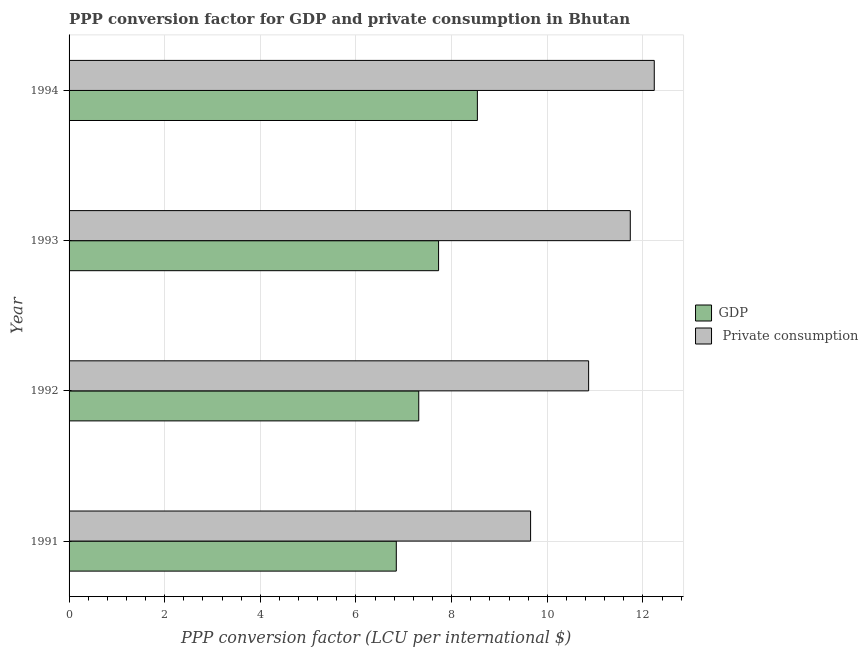How many different coloured bars are there?
Offer a very short reply. 2. How many groups of bars are there?
Your answer should be compact. 4. Are the number of bars per tick equal to the number of legend labels?
Offer a terse response. Yes. Are the number of bars on each tick of the Y-axis equal?
Your answer should be very brief. Yes. What is the label of the 2nd group of bars from the top?
Provide a succinct answer. 1993. What is the ppp conversion factor for private consumption in 1991?
Provide a succinct answer. 9.65. Across all years, what is the maximum ppp conversion factor for private consumption?
Provide a succinct answer. 12.24. Across all years, what is the minimum ppp conversion factor for gdp?
Your answer should be compact. 6.84. In which year was the ppp conversion factor for gdp minimum?
Keep it short and to the point. 1991. What is the total ppp conversion factor for private consumption in the graph?
Give a very brief answer. 44.49. What is the difference between the ppp conversion factor for private consumption in 1991 and that in 1993?
Your response must be concise. -2.08. What is the difference between the ppp conversion factor for gdp in 1994 and the ppp conversion factor for private consumption in 1993?
Offer a very short reply. -3.2. What is the average ppp conversion factor for gdp per year?
Give a very brief answer. 7.61. In the year 1994, what is the difference between the ppp conversion factor for private consumption and ppp conversion factor for gdp?
Ensure brevity in your answer.  3.7. What is the ratio of the ppp conversion factor for gdp in 1991 to that in 1992?
Your answer should be very brief. 0.94. Is the difference between the ppp conversion factor for private consumption in 1991 and 1992 greater than the difference between the ppp conversion factor for gdp in 1991 and 1992?
Ensure brevity in your answer.  No. What is the difference between the highest and the second highest ppp conversion factor for private consumption?
Your answer should be very brief. 0.5. What is the difference between the highest and the lowest ppp conversion factor for private consumption?
Give a very brief answer. 2.59. In how many years, is the ppp conversion factor for gdp greater than the average ppp conversion factor for gdp taken over all years?
Offer a terse response. 2. What does the 2nd bar from the top in 1992 represents?
Offer a very short reply. GDP. What does the 1st bar from the bottom in 1994 represents?
Make the answer very short. GDP. How many bars are there?
Your response must be concise. 8. Are all the bars in the graph horizontal?
Your response must be concise. Yes. How many years are there in the graph?
Your answer should be compact. 4. Does the graph contain any zero values?
Make the answer very short. No. Does the graph contain grids?
Provide a short and direct response. Yes. How many legend labels are there?
Your answer should be very brief. 2. What is the title of the graph?
Provide a succinct answer. PPP conversion factor for GDP and private consumption in Bhutan. What is the label or title of the X-axis?
Offer a terse response. PPP conversion factor (LCU per international $). What is the PPP conversion factor (LCU per international $) of GDP in 1991?
Give a very brief answer. 6.84. What is the PPP conversion factor (LCU per international $) of  Private consumption in 1991?
Your response must be concise. 9.65. What is the PPP conversion factor (LCU per international $) in GDP in 1992?
Offer a very short reply. 7.31. What is the PPP conversion factor (LCU per international $) in  Private consumption in 1992?
Provide a short and direct response. 10.86. What is the PPP conversion factor (LCU per international $) of GDP in 1993?
Your answer should be very brief. 7.73. What is the PPP conversion factor (LCU per international $) of  Private consumption in 1993?
Provide a short and direct response. 11.74. What is the PPP conversion factor (LCU per international $) of GDP in 1994?
Offer a terse response. 8.54. What is the PPP conversion factor (LCU per international $) of  Private consumption in 1994?
Offer a very short reply. 12.24. Across all years, what is the maximum PPP conversion factor (LCU per international $) in GDP?
Provide a short and direct response. 8.54. Across all years, what is the maximum PPP conversion factor (LCU per international $) of  Private consumption?
Make the answer very short. 12.24. Across all years, what is the minimum PPP conversion factor (LCU per international $) of GDP?
Your answer should be compact. 6.84. Across all years, what is the minimum PPP conversion factor (LCU per international $) in  Private consumption?
Offer a terse response. 9.65. What is the total PPP conversion factor (LCU per international $) of GDP in the graph?
Keep it short and to the point. 30.42. What is the total PPP conversion factor (LCU per international $) in  Private consumption in the graph?
Your response must be concise. 44.49. What is the difference between the PPP conversion factor (LCU per international $) of GDP in 1991 and that in 1992?
Provide a succinct answer. -0.47. What is the difference between the PPP conversion factor (LCU per international $) of  Private consumption in 1991 and that in 1992?
Your response must be concise. -1.21. What is the difference between the PPP conversion factor (LCU per international $) of GDP in 1991 and that in 1993?
Give a very brief answer. -0.88. What is the difference between the PPP conversion factor (LCU per international $) in  Private consumption in 1991 and that in 1993?
Offer a terse response. -2.08. What is the difference between the PPP conversion factor (LCU per international $) of GDP in 1991 and that in 1994?
Your answer should be compact. -1.7. What is the difference between the PPP conversion factor (LCU per international $) in  Private consumption in 1991 and that in 1994?
Offer a terse response. -2.59. What is the difference between the PPP conversion factor (LCU per international $) of GDP in 1992 and that in 1993?
Offer a very short reply. -0.41. What is the difference between the PPP conversion factor (LCU per international $) in  Private consumption in 1992 and that in 1993?
Your answer should be very brief. -0.87. What is the difference between the PPP conversion factor (LCU per international $) in GDP in 1992 and that in 1994?
Your answer should be compact. -1.23. What is the difference between the PPP conversion factor (LCU per international $) of  Private consumption in 1992 and that in 1994?
Your response must be concise. -1.37. What is the difference between the PPP conversion factor (LCU per international $) of GDP in 1993 and that in 1994?
Offer a terse response. -0.81. What is the difference between the PPP conversion factor (LCU per international $) in  Private consumption in 1993 and that in 1994?
Provide a succinct answer. -0.5. What is the difference between the PPP conversion factor (LCU per international $) in GDP in 1991 and the PPP conversion factor (LCU per international $) in  Private consumption in 1992?
Give a very brief answer. -4.02. What is the difference between the PPP conversion factor (LCU per international $) of GDP in 1991 and the PPP conversion factor (LCU per international $) of  Private consumption in 1993?
Your response must be concise. -4.89. What is the difference between the PPP conversion factor (LCU per international $) in GDP in 1991 and the PPP conversion factor (LCU per international $) in  Private consumption in 1994?
Make the answer very short. -5.39. What is the difference between the PPP conversion factor (LCU per international $) of GDP in 1992 and the PPP conversion factor (LCU per international $) of  Private consumption in 1993?
Ensure brevity in your answer.  -4.42. What is the difference between the PPP conversion factor (LCU per international $) of GDP in 1992 and the PPP conversion factor (LCU per international $) of  Private consumption in 1994?
Provide a succinct answer. -4.93. What is the difference between the PPP conversion factor (LCU per international $) in GDP in 1993 and the PPP conversion factor (LCU per international $) in  Private consumption in 1994?
Provide a succinct answer. -4.51. What is the average PPP conversion factor (LCU per international $) in GDP per year?
Keep it short and to the point. 7.61. What is the average PPP conversion factor (LCU per international $) of  Private consumption per year?
Make the answer very short. 11.12. In the year 1991, what is the difference between the PPP conversion factor (LCU per international $) in GDP and PPP conversion factor (LCU per international $) in  Private consumption?
Your answer should be very brief. -2.81. In the year 1992, what is the difference between the PPP conversion factor (LCU per international $) of GDP and PPP conversion factor (LCU per international $) of  Private consumption?
Your answer should be compact. -3.55. In the year 1993, what is the difference between the PPP conversion factor (LCU per international $) in GDP and PPP conversion factor (LCU per international $) in  Private consumption?
Your answer should be very brief. -4.01. In the year 1994, what is the difference between the PPP conversion factor (LCU per international $) of GDP and PPP conversion factor (LCU per international $) of  Private consumption?
Provide a succinct answer. -3.7. What is the ratio of the PPP conversion factor (LCU per international $) of GDP in 1991 to that in 1992?
Provide a succinct answer. 0.94. What is the ratio of the PPP conversion factor (LCU per international $) in  Private consumption in 1991 to that in 1992?
Offer a very short reply. 0.89. What is the ratio of the PPP conversion factor (LCU per international $) of GDP in 1991 to that in 1993?
Make the answer very short. 0.89. What is the ratio of the PPP conversion factor (LCU per international $) of  Private consumption in 1991 to that in 1993?
Keep it short and to the point. 0.82. What is the ratio of the PPP conversion factor (LCU per international $) of GDP in 1991 to that in 1994?
Keep it short and to the point. 0.8. What is the ratio of the PPP conversion factor (LCU per international $) of  Private consumption in 1991 to that in 1994?
Your answer should be compact. 0.79. What is the ratio of the PPP conversion factor (LCU per international $) in GDP in 1992 to that in 1993?
Make the answer very short. 0.95. What is the ratio of the PPP conversion factor (LCU per international $) in  Private consumption in 1992 to that in 1993?
Provide a short and direct response. 0.93. What is the ratio of the PPP conversion factor (LCU per international $) of GDP in 1992 to that in 1994?
Ensure brevity in your answer.  0.86. What is the ratio of the PPP conversion factor (LCU per international $) in  Private consumption in 1992 to that in 1994?
Your response must be concise. 0.89. What is the ratio of the PPP conversion factor (LCU per international $) in GDP in 1993 to that in 1994?
Offer a terse response. 0.91. What is the difference between the highest and the second highest PPP conversion factor (LCU per international $) of GDP?
Keep it short and to the point. 0.81. What is the difference between the highest and the second highest PPP conversion factor (LCU per international $) of  Private consumption?
Provide a short and direct response. 0.5. What is the difference between the highest and the lowest PPP conversion factor (LCU per international $) in GDP?
Make the answer very short. 1.7. What is the difference between the highest and the lowest PPP conversion factor (LCU per international $) of  Private consumption?
Your answer should be compact. 2.59. 